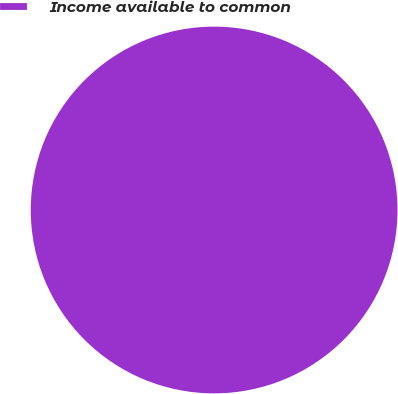Convert chart to OTSL. <chart><loc_0><loc_0><loc_500><loc_500><pie_chart><fcel>Income available to common<nl><fcel>100.0%<nl></chart> 